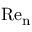<formula> <loc_0><loc_0><loc_500><loc_500>R e _ { n }</formula> 